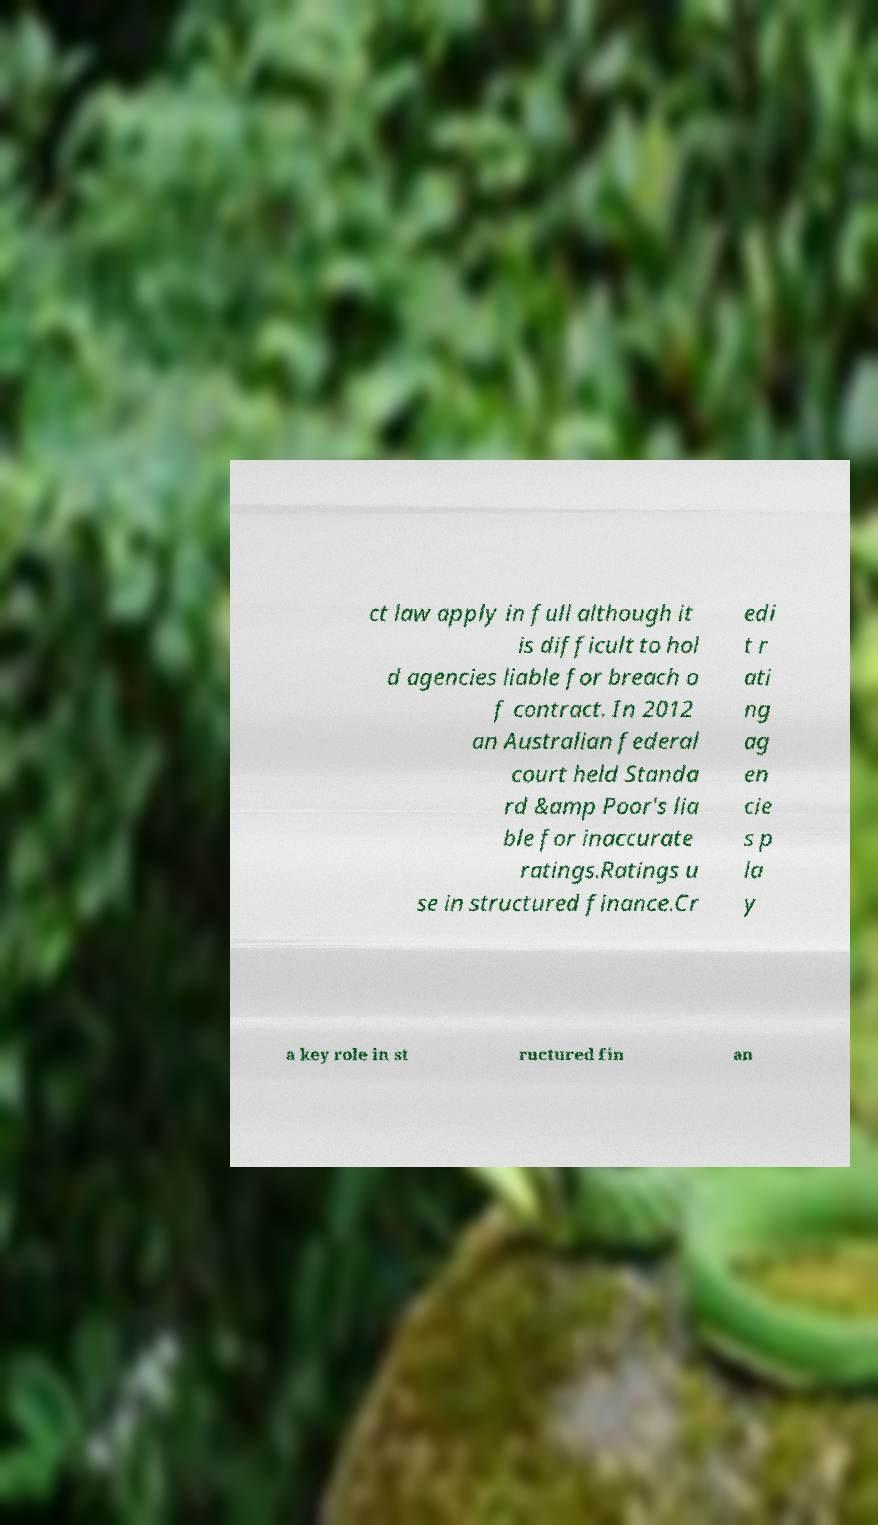Can you accurately transcribe the text from the provided image for me? ct law apply in full although it is difficult to hol d agencies liable for breach o f contract. In 2012 an Australian federal court held Standa rd &amp Poor's lia ble for inaccurate ratings.Ratings u se in structured finance.Cr edi t r ati ng ag en cie s p la y a key role in st ructured fin an 